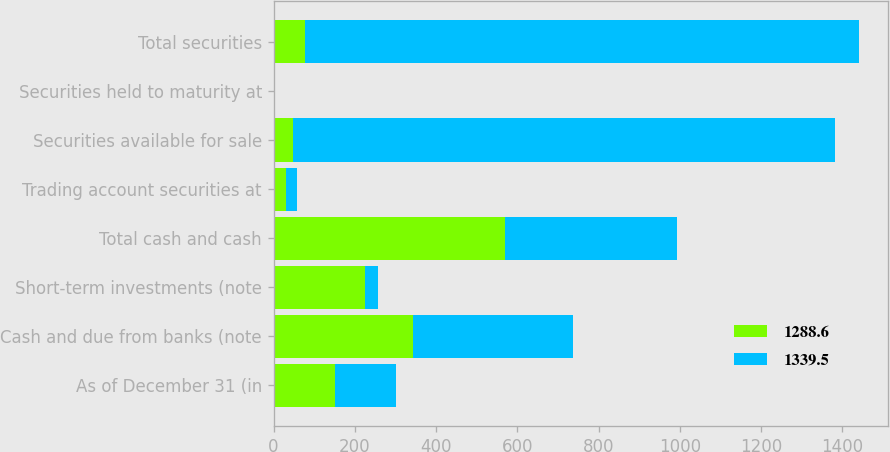Convert chart. <chart><loc_0><loc_0><loc_500><loc_500><stacked_bar_chart><ecel><fcel>As of December 31 (in<fcel>Cash and due from banks (note<fcel>Short-term investments (note<fcel>Total cash and cash<fcel>Trading account securities at<fcel>Securities available for sale<fcel>Securities held to maturity at<fcel>Total securities<nl><fcel>1288.6<fcel>151.05<fcel>344.1<fcel>224.6<fcel>568.7<fcel>29.6<fcel>46.8<fcel>1.1<fcel>77.5<nl><fcel>1339.5<fcel>151.05<fcel>391.6<fcel>31.9<fcel>423.5<fcel>27.3<fcel>1334.3<fcel>1.4<fcel>1363<nl></chart> 